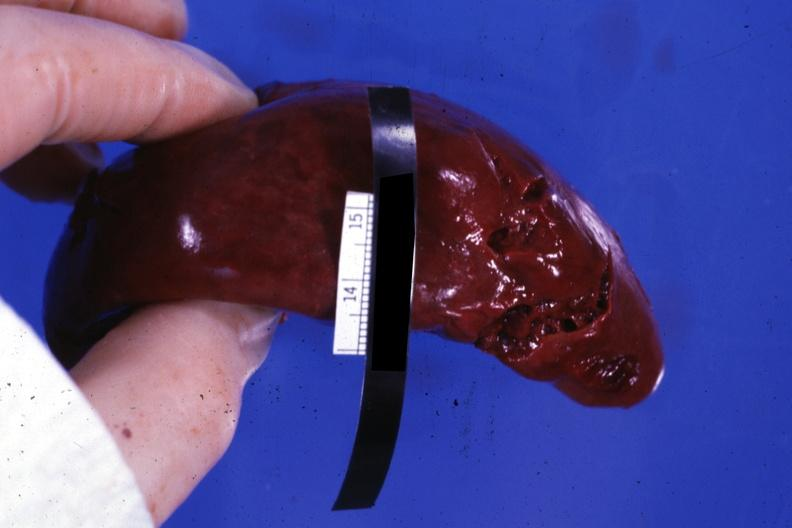s spleen present?
Answer the question using a single word or phrase. Yes 